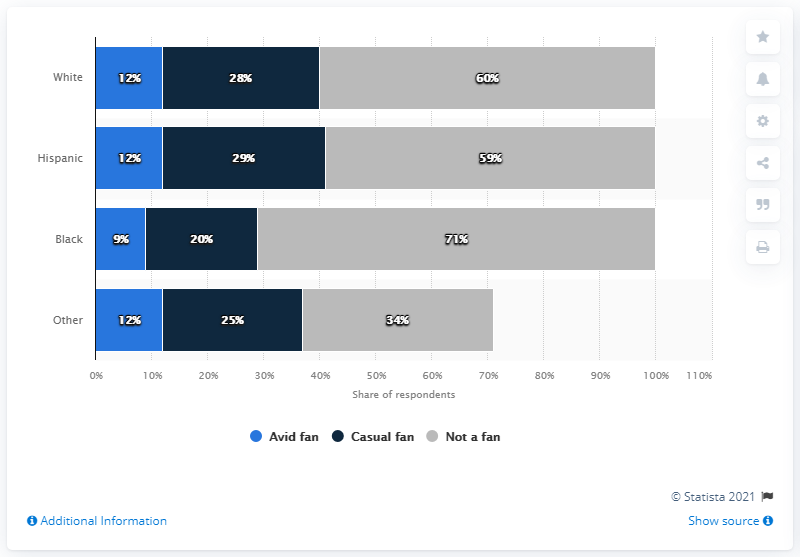List a handful of essential elements in this visual. According to a May 2021 survey, approximately 12% of Hispanic avid fans of the NHL in the United States are interested in the sport. According to a survey conducted in May 2021, the difference in percentage between the maximum casual fans and the most avid fans of NHL in the United States is [X]%. 